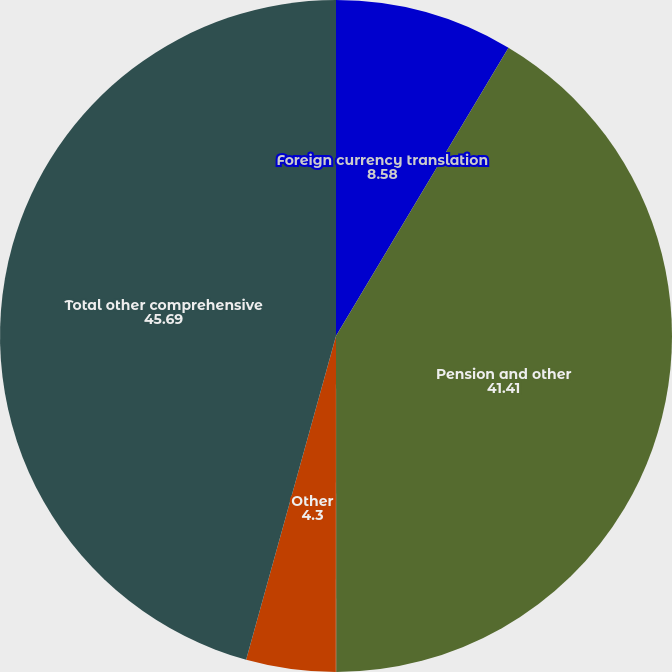<chart> <loc_0><loc_0><loc_500><loc_500><pie_chart><fcel>Foreign currency translation<fcel>Pension and other<fcel>Changes in fair value of cash<fcel>Other<fcel>Total other comprehensive<nl><fcel>8.58%<fcel>41.41%<fcel>0.02%<fcel>4.3%<fcel>45.69%<nl></chart> 